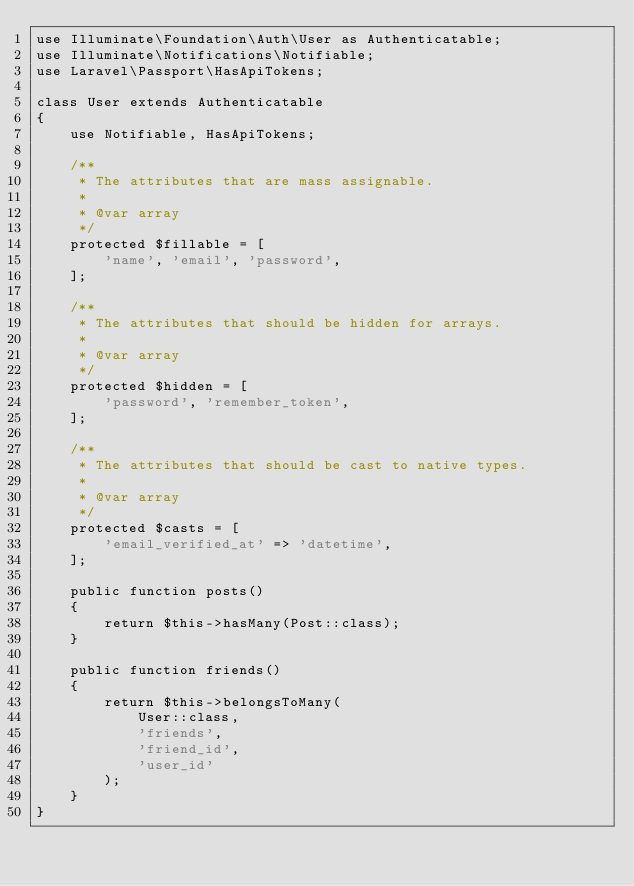<code> <loc_0><loc_0><loc_500><loc_500><_PHP_>use Illuminate\Foundation\Auth\User as Authenticatable;
use Illuminate\Notifications\Notifiable;
use Laravel\Passport\HasApiTokens;

class User extends Authenticatable
{
    use Notifiable, HasApiTokens;

    /**
     * The attributes that are mass assignable.
     *
     * @var array
     */
    protected $fillable = [
        'name', 'email', 'password',
    ];

    /**
     * The attributes that should be hidden for arrays.
     *
     * @var array
     */
    protected $hidden = [
        'password', 'remember_token',
    ];

    /**
     * The attributes that should be cast to native types.
     *
     * @var array
     */
    protected $casts = [
        'email_verified_at' => 'datetime',
    ];

    public function posts()
    {
        return $this->hasMany(Post::class);
    }

    public function friends()
    {
        return $this->belongsToMany(
            User::class,
            'friends',
            'friend_id',
            'user_id'
        );
    }
}
</code> 